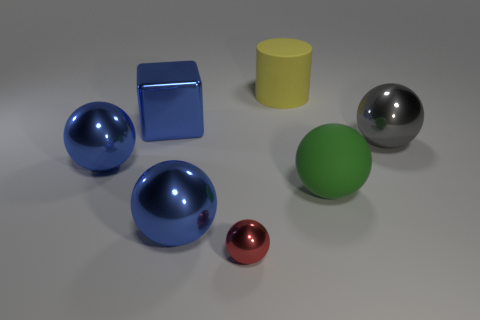Are there any other things that are the same size as the red metallic object?
Offer a terse response. No. What number of big spheres have the same color as the large shiny cube?
Offer a terse response. 2. Is the number of matte objects greater than the number of cylinders?
Offer a very short reply. Yes. There is a matte object behind the metal thing that is on the right side of the small ball; how big is it?
Your response must be concise. Large. The tiny metal object that is the same shape as the large gray metal object is what color?
Keep it short and to the point. Red. What size is the cylinder?
Ensure brevity in your answer.  Large. How many cylinders are either yellow things or blue objects?
Give a very brief answer. 1. There is a red object that is the same shape as the gray metallic thing; what is its size?
Your answer should be compact. Small. How many green blocks are there?
Provide a short and direct response. 0. There is a large yellow thing; is it the same shape as the large shiny object that is on the left side of the metal block?
Provide a succinct answer. No. 